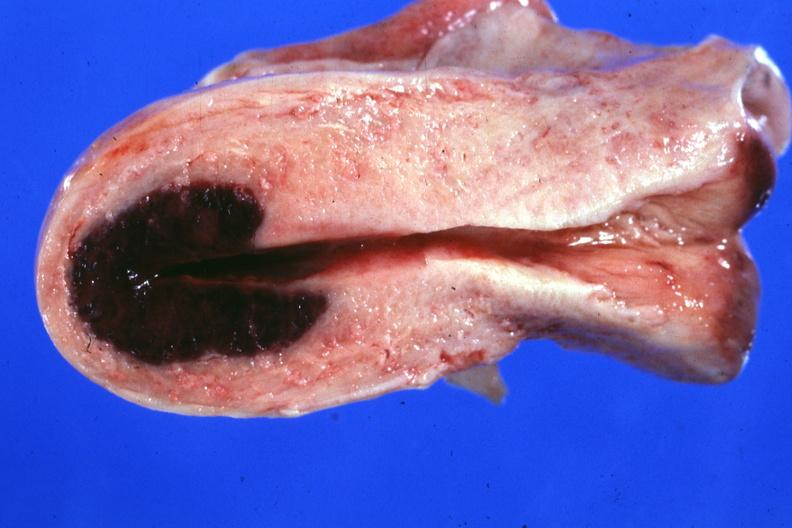why is lesion in dome of uterus said to have adenosis adenomyosis hemorrhage probably?
Answer the question using a single word or phrase. Due shock 